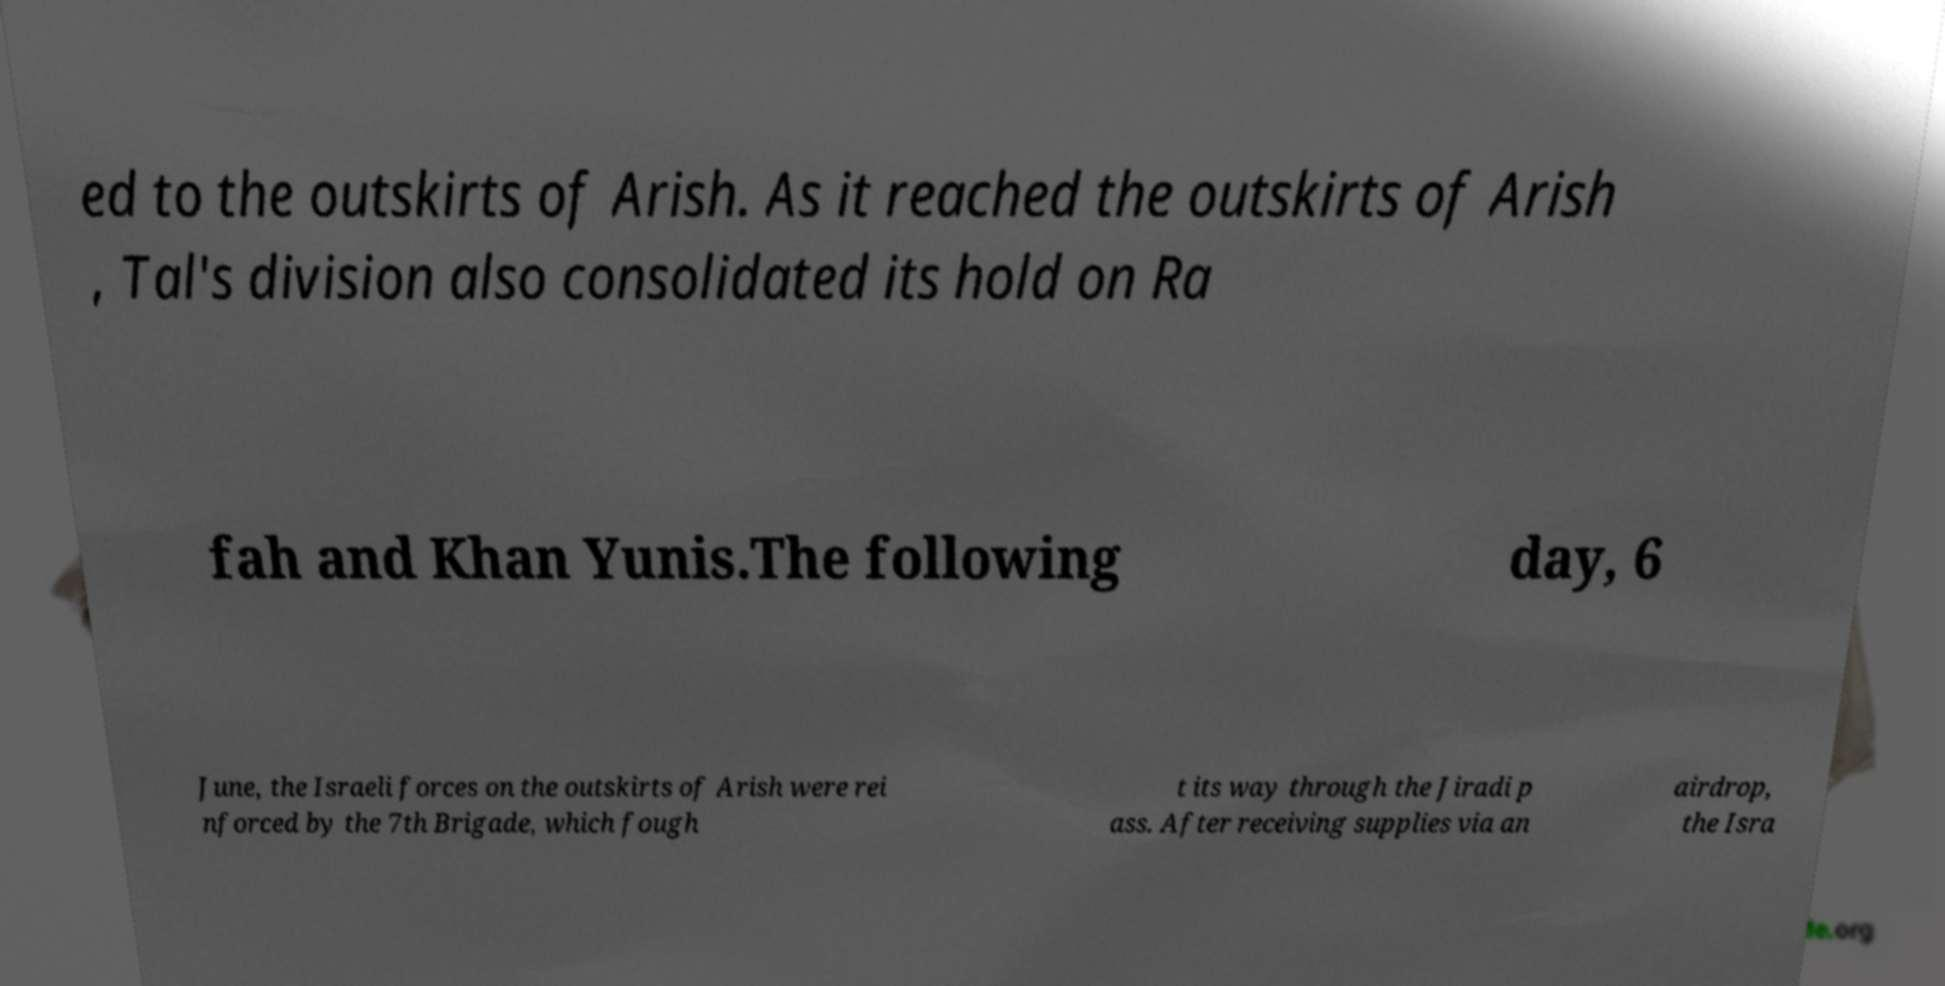Can you read and provide the text displayed in the image?This photo seems to have some interesting text. Can you extract and type it out for me? ed to the outskirts of Arish. As it reached the outskirts of Arish , Tal's division also consolidated its hold on Ra fah and Khan Yunis.The following day, 6 June, the Israeli forces on the outskirts of Arish were rei nforced by the 7th Brigade, which fough t its way through the Jiradi p ass. After receiving supplies via an airdrop, the Isra 